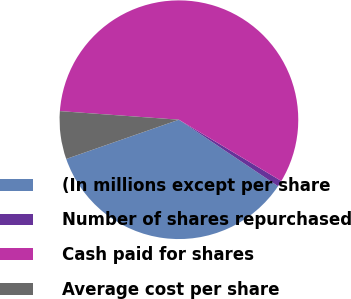Convert chart. <chart><loc_0><loc_0><loc_500><loc_500><pie_chart><fcel>(In millions except per share<fcel>Number of shares repurchased<fcel>Cash paid for shares<fcel>Average cost per share<nl><fcel>35.26%<fcel>0.82%<fcel>57.43%<fcel>6.48%<nl></chart> 